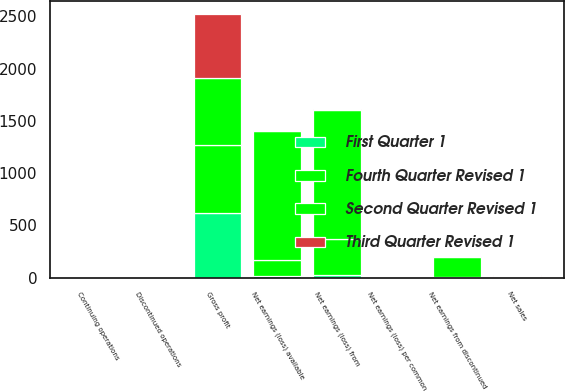<chart> <loc_0><loc_0><loc_500><loc_500><stacked_bar_chart><ecel><fcel>Net sales<fcel>Gross profit<fcel>Net earnings (loss) from<fcel>Net earnings from discontinued<fcel>Net earnings (loss) available<fcel>Continuing operations<fcel>Discontinued operations<fcel>Net earnings (loss) per common<nl><fcel>Third Quarter Revised 1<fcel>7.01<fcel>615.3<fcel>10.1<fcel>4.1<fcel>6<fcel>0.05<fcel>0.02<fcel>0.03<nl><fcel>First Quarter 1<fcel>7.01<fcel>622.7<fcel>22.6<fcel>9<fcel>13.6<fcel>0.12<fcel>0.05<fcel>0.07<nl><fcel>Second Quarter Revised 1<fcel>7.01<fcel>638.3<fcel>1240<fcel>7.6<fcel>1232.4<fcel>6.42<fcel>0.04<fcel>6.38<nl><fcel>Fourth Quarter Revised 1<fcel>7.01<fcel>646<fcel>345.2<fcel>186.9<fcel>158.3<fcel>1.79<fcel>0.97<fcel>0.82<nl></chart> 